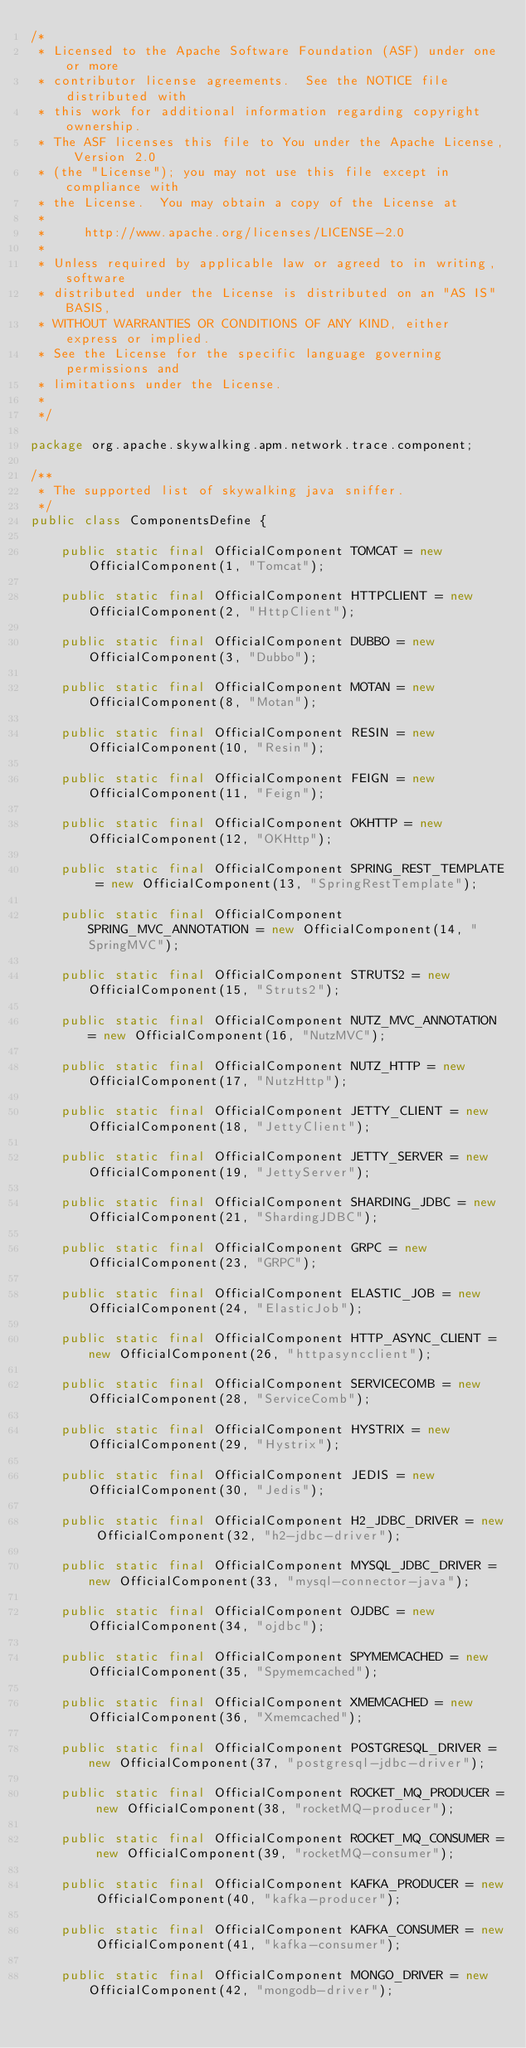Convert code to text. <code><loc_0><loc_0><loc_500><loc_500><_Java_>/*
 * Licensed to the Apache Software Foundation (ASF) under one or more
 * contributor license agreements.  See the NOTICE file distributed with
 * this work for additional information regarding copyright ownership.
 * The ASF licenses this file to You under the Apache License, Version 2.0
 * (the "License"); you may not use this file except in compliance with
 * the License.  You may obtain a copy of the License at
 *
 *     http://www.apache.org/licenses/LICENSE-2.0
 *
 * Unless required by applicable law or agreed to in writing, software
 * distributed under the License is distributed on an "AS IS" BASIS,
 * WITHOUT WARRANTIES OR CONDITIONS OF ANY KIND, either express or implied.
 * See the License for the specific language governing permissions and
 * limitations under the License.
 *
 */

package org.apache.skywalking.apm.network.trace.component;

/**
 * The supported list of skywalking java sniffer.
 */
public class ComponentsDefine {

    public static final OfficialComponent TOMCAT = new OfficialComponent(1, "Tomcat");

    public static final OfficialComponent HTTPCLIENT = new OfficialComponent(2, "HttpClient");

    public static final OfficialComponent DUBBO = new OfficialComponent(3, "Dubbo");

    public static final OfficialComponent MOTAN = new OfficialComponent(8, "Motan");

    public static final OfficialComponent RESIN = new OfficialComponent(10, "Resin");

    public static final OfficialComponent FEIGN = new OfficialComponent(11, "Feign");

    public static final OfficialComponent OKHTTP = new OfficialComponent(12, "OKHttp");

    public static final OfficialComponent SPRING_REST_TEMPLATE = new OfficialComponent(13, "SpringRestTemplate");

    public static final OfficialComponent SPRING_MVC_ANNOTATION = new OfficialComponent(14, "SpringMVC");

    public static final OfficialComponent STRUTS2 = new OfficialComponent(15, "Struts2");

    public static final OfficialComponent NUTZ_MVC_ANNOTATION = new OfficialComponent(16, "NutzMVC");

    public static final OfficialComponent NUTZ_HTTP = new OfficialComponent(17, "NutzHttp");

    public static final OfficialComponent JETTY_CLIENT = new OfficialComponent(18, "JettyClient");

    public static final OfficialComponent JETTY_SERVER = new OfficialComponent(19, "JettyServer");

    public static final OfficialComponent SHARDING_JDBC = new OfficialComponent(21, "ShardingJDBC");

    public static final OfficialComponent GRPC = new OfficialComponent(23, "GRPC");

    public static final OfficialComponent ELASTIC_JOB = new OfficialComponent(24, "ElasticJob");

    public static final OfficialComponent HTTP_ASYNC_CLIENT = new OfficialComponent(26, "httpasyncclient");

    public static final OfficialComponent SERVICECOMB = new OfficialComponent(28, "ServiceComb");

    public static final OfficialComponent HYSTRIX = new OfficialComponent(29, "Hystrix");

    public static final OfficialComponent JEDIS = new OfficialComponent(30, "Jedis");

    public static final OfficialComponent H2_JDBC_DRIVER = new OfficialComponent(32, "h2-jdbc-driver");

    public static final OfficialComponent MYSQL_JDBC_DRIVER = new OfficialComponent(33, "mysql-connector-java");

    public static final OfficialComponent OJDBC = new OfficialComponent(34, "ojdbc");

    public static final OfficialComponent SPYMEMCACHED = new OfficialComponent(35, "Spymemcached");

    public static final OfficialComponent XMEMCACHED = new OfficialComponent(36, "Xmemcached");

    public static final OfficialComponent POSTGRESQL_DRIVER = new OfficialComponent(37, "postgresql-jdbc-driver");

    public static final OfficialComponent ROCKET_MQ_PRODUCER = new OfficialComponent(38, "rocketMQ-producer");

    public static final OfficialComponent ROCKET_MQ_CONSUMER = new OfficialComponent(39, "rocketMQ-consumer");

    public static final OfficialComponent KAFKA_PRODUCER = new OfficialComponent(40, "kafka-producer");

    public static final OfficialComponent KAFKA_CONSUMER = new OfficialComponent(41, "kafka-consumer");

    public static final OfficialComponent MONGO_DRIVER = new OfficialComponent(42, "mongodb-driver");
</code> 